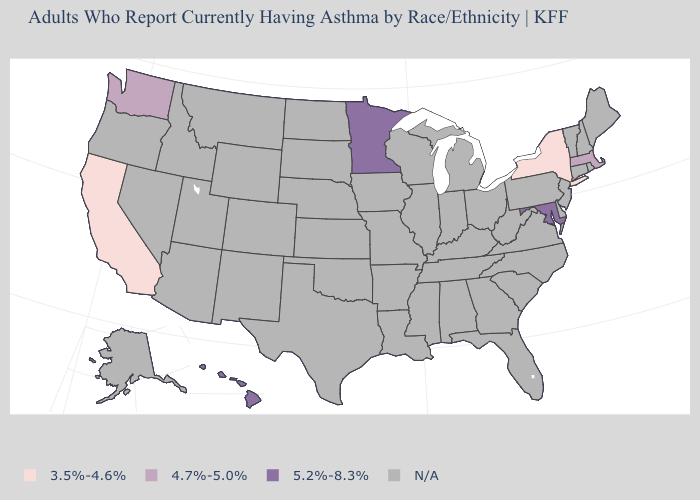Which states have the highest value in the USA?
Write a very short answer. Hawaii, Maryland, Minnesota. Name the states that have a value in the range 3.5%-4.6%?
Concise answer only. California, New York. What is the value of Virginia?
Give a very brief answer. N/A. Does California have the lowest value in the USA?
Short answer required. Yes. Which states have the highest value in the USA?
Write a very short answer. Hawaii, Maryland, Minnesota. What is the value of New Jersey?
Concise answer only. N/A. What is the highest value in states that border Nevada?
Quick response, please. 3.5%-4.6%. What is the value of Missouri?
Quick response, please. N/A. What is the value of Alabama?
Short answer required. N/A. Does California have the lowest value in the USA?
Answer briefly. Yes. What is the value of Georgia?
Write a very short answer. N/A. 